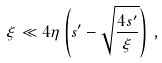Convert formula to latex. <formula><loc_0><loc_0><loc_500><loc_500>\xi \ll 4 \eta \left ( s ^ { \prime } - \sqrt { \frac { 4 s ^ { \prime } } { \xi } } \right ) \, ,</formula> 